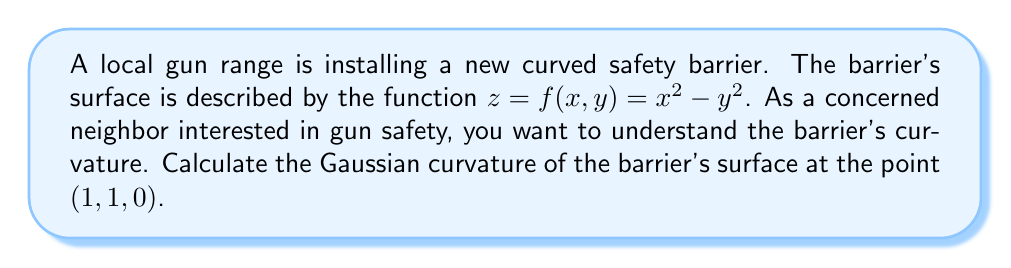Show me your answer to this math problem. To compute the Gaussian curvature, we'll follow these steps:

1) The Gaussian curvature K is given by:
   $$K = \frac{LN - M^2}{EG - F^2}$$
   where L, M, N are coefficients of the second fundamental form, and E, F, G are coefficients of the first fundamental form.

2) First, we need to calculate the partial derivatives:
   $$f_x = 2x, \quad f_y = -2y, \quad f_{xx} = 2, \quad f_{yy} = -2, \quad f_{xy} = 0$$

3) Now we can calculate E, F, and G:
   $$E = 1 + f_x^2 = 1 + 4x^2$$
   $$F = f_x f_y = -4xy$$
   $$G = 1 + f_y^2 = 1 + 4y^2$$

4) Next, we calculate the unit normal vector:
   $$\vec{n} = \frac{(-f_x, -f_y, 1)}{\sqrt{1 + f_x^2 + f_y^2}} = \frac{(-2x, 2y, 1)}{\sqrt{1 + 4x^2 + 4y^2}}$$

5) Now we can calculate L, M, and N:
   $$L = \frac{f_{xx}}{\sqrt{1 + f_x^2 + f_y^2}} = \frac{2}{\sqrt{1 + 4x^2 + 4y^2}}$$
   $$M = \frac{f_{xy}}{\sqrt{1 + f_x^2 + f_y^2}} = 0$$
   $$N = \frac{f_{yy}}{\sqrt{1 + f_x^2 + f_y^2}} = \frac{-2}{\sqrt{1 + 4x^2 + 4y^2}}$$

6) At the point (1, 1, 0), we can now calculate:
   $$E = 5, \quad F = -4, \quad G = 5$$
   $$L = \frac{2}{3}, \quad M = 0, \quad N = -\frac{2}{3}$$

7) Finally, we can compute the Gaussian curvature:
   $$K = \frac{LN - M^2}{EG - F^2} = \frac{(\frac{2}{3})(-\frac{2}{3}) - 0^2}{(5)(5) - (-4)^2} = \frac{-\frac{4}{9}}{9} = -\frac{4}{81}$$
Answer: $-\frac{4}{81}$ 